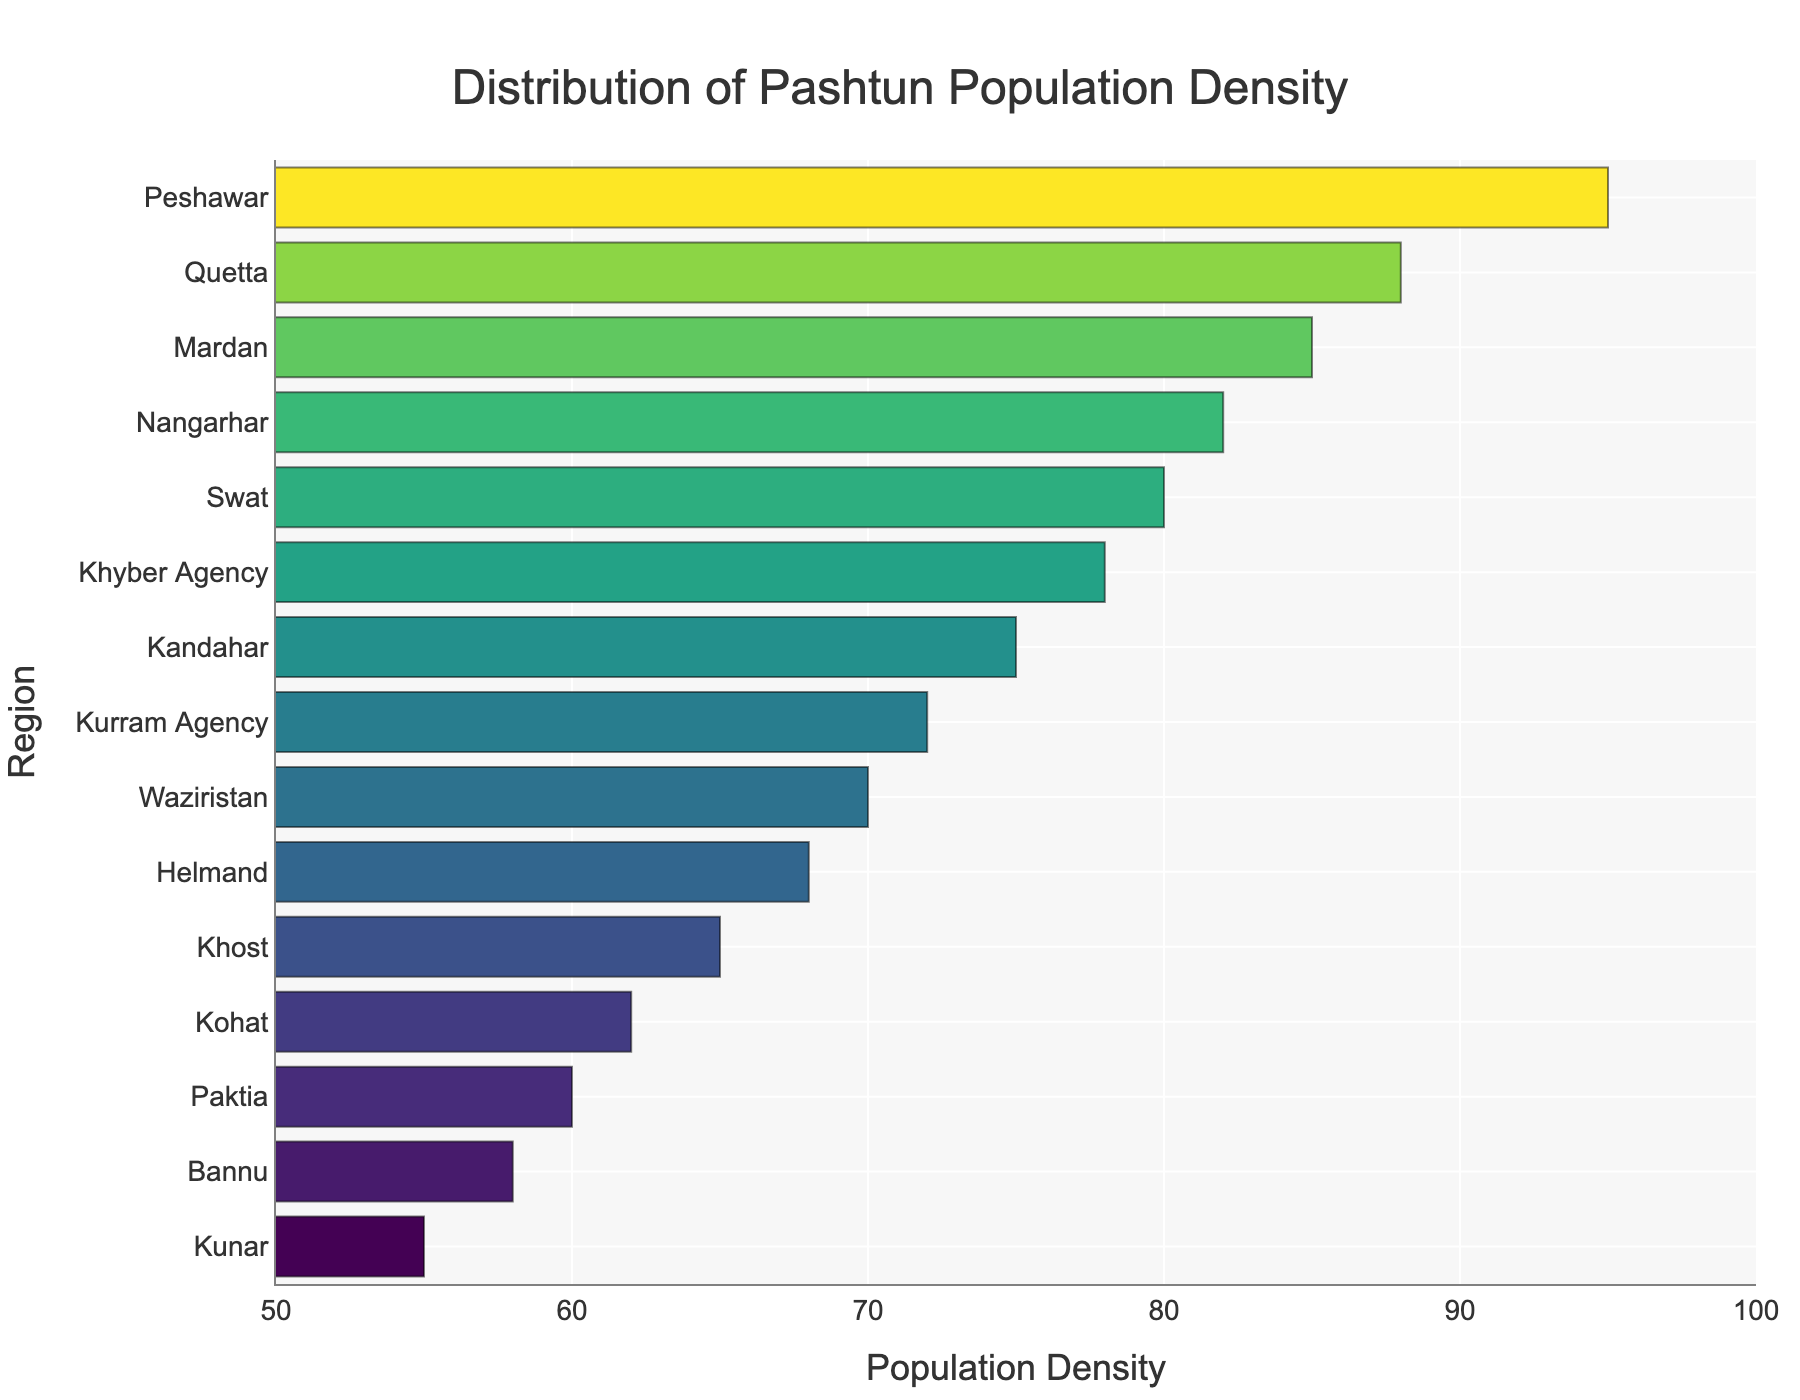Which region has the highest Pashtun population density? The highest bar in the plot corresponds to the region with the highest population density. From the plot, this is Peshawar.
Answer: Peshawar Which region has the lowest Pashtun population density? The lowest bar in the plot corresponds to the region with the lowest population density. From the plot, this is Kunar with a density of 55.
Answer: Kunar How many regions have a Pashtun population density higher than 80? Identify all the bars with a population density greater than 80. These regions are Nangarhar, Peshawar, Quetta, and Mardan. Hence, there are 4 regions.
Answer: 4 What is the average population density among all the regions? Sum up the population densities and divide by the total number of regions. Sum = 75+82+68+60+65+55+95+88+70+78+72+80+85+62+58 = 1093. Dividing by 15 regions, the average is 1093/15 ≈ 72.87.
Answer: 72.87 Which region has a higher Pashtun population density, Quetta or Kandahar? Locate the bars for Quetta and Kandahar. The population density of Quetta is 88, and for Kandahar, it is 75. Comparing the two, Quetta has a higher density.
Answer: Quetta What is the population density difference between Swat and Kunar? Locate the bars for Swat and Kunar. The population density of Swat is 80 and for Kunar, it is 55. The difference is 80 - 55 = 25.
Answer: 25 What is the median Pashtun population density of all the regions? Sort the population densities and find the middle value. Sorted Densities: 55, 58, 60, 62, 65, 68, 70, 72, 75, 78, 80, 82, 85, 88, 95. The median value (8th in this case) is 72.
Answer: 72 Which region has a population density closest to the overall average? The average population density is 72.87. Compare this with the population densities of all regions and find the closest value. The closest is Paktia with 72.
Answer: Paktia Are there more regions with a population density below 70 or above 70? Count the number of regions below and above 70. Below 70: Helmand, Paktia, Khost, Kunar, Kohat, Bannu (6 regions). Above 70: Kandahar, Nangarhar, Peshawar, Quetta, Waziristan, Khyber Agency, Kurram Agency, Swat, Mardan (9 regions). There are more regions above 70.
Answer: Above 70 